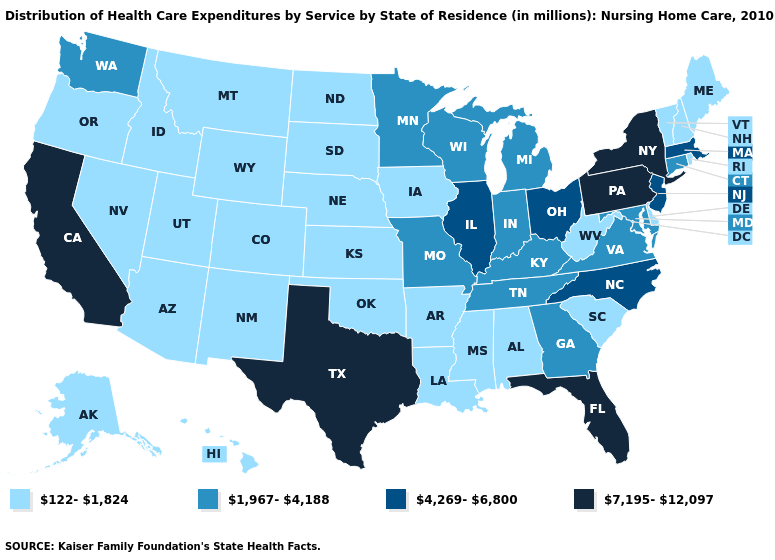Which states hav the highest value in the South?
Quick response, please. Florida, Texas. Among the states that border South Carolina , which have the lowest value?
Answer briefly. Georgia. Name the states that have a value in the range 122-1,824?
Short answer required. Alabama, Alaska, Arizona, Arkansas, Colorado, Delaware, Hawaii, Idaho, Iowa, Kansas, Louisiana, Maine, Mississippi, Montana, Nebraska, Nevada, New Hampshire, New Mexico, North Dakota, Oklahoma, Oregon, Rhode Island, South Carolina, South Dakota, Utah, Vermont, West Virginia, Wyoming. How many symbols are there in the legend?
Concise answer only. 4. How many symbols are there in the legend?
Keep it brief. 4. Among the states that border Indiana , does Kentucky have the highest value?
Write a very short answer. No. What is the highest value in states that border Iowa?
Quick response, please. 4,269-6,800. What is the value of Georgia?
Short answer required. 1,967-4,188. Which states have the highest value in the USA?
Keep it brief. California, Florida, New York, Pennsylvania, Texas. What is the value of Iowa?
Be succinct. 122-1,824. Does Florida have a higher value than Pennsylvania?
Give a very brief answer. No. What is the value of North Carolina?
Concise answer only. 4,269-6,800. What is the value of South Carolina?
Be succinct. 122-1,824. What is the value of Connecticut?
Quick response, please. 1,967-4,188. What is the value of Georgia?
Write a very short answer. 1,967-4,188. 